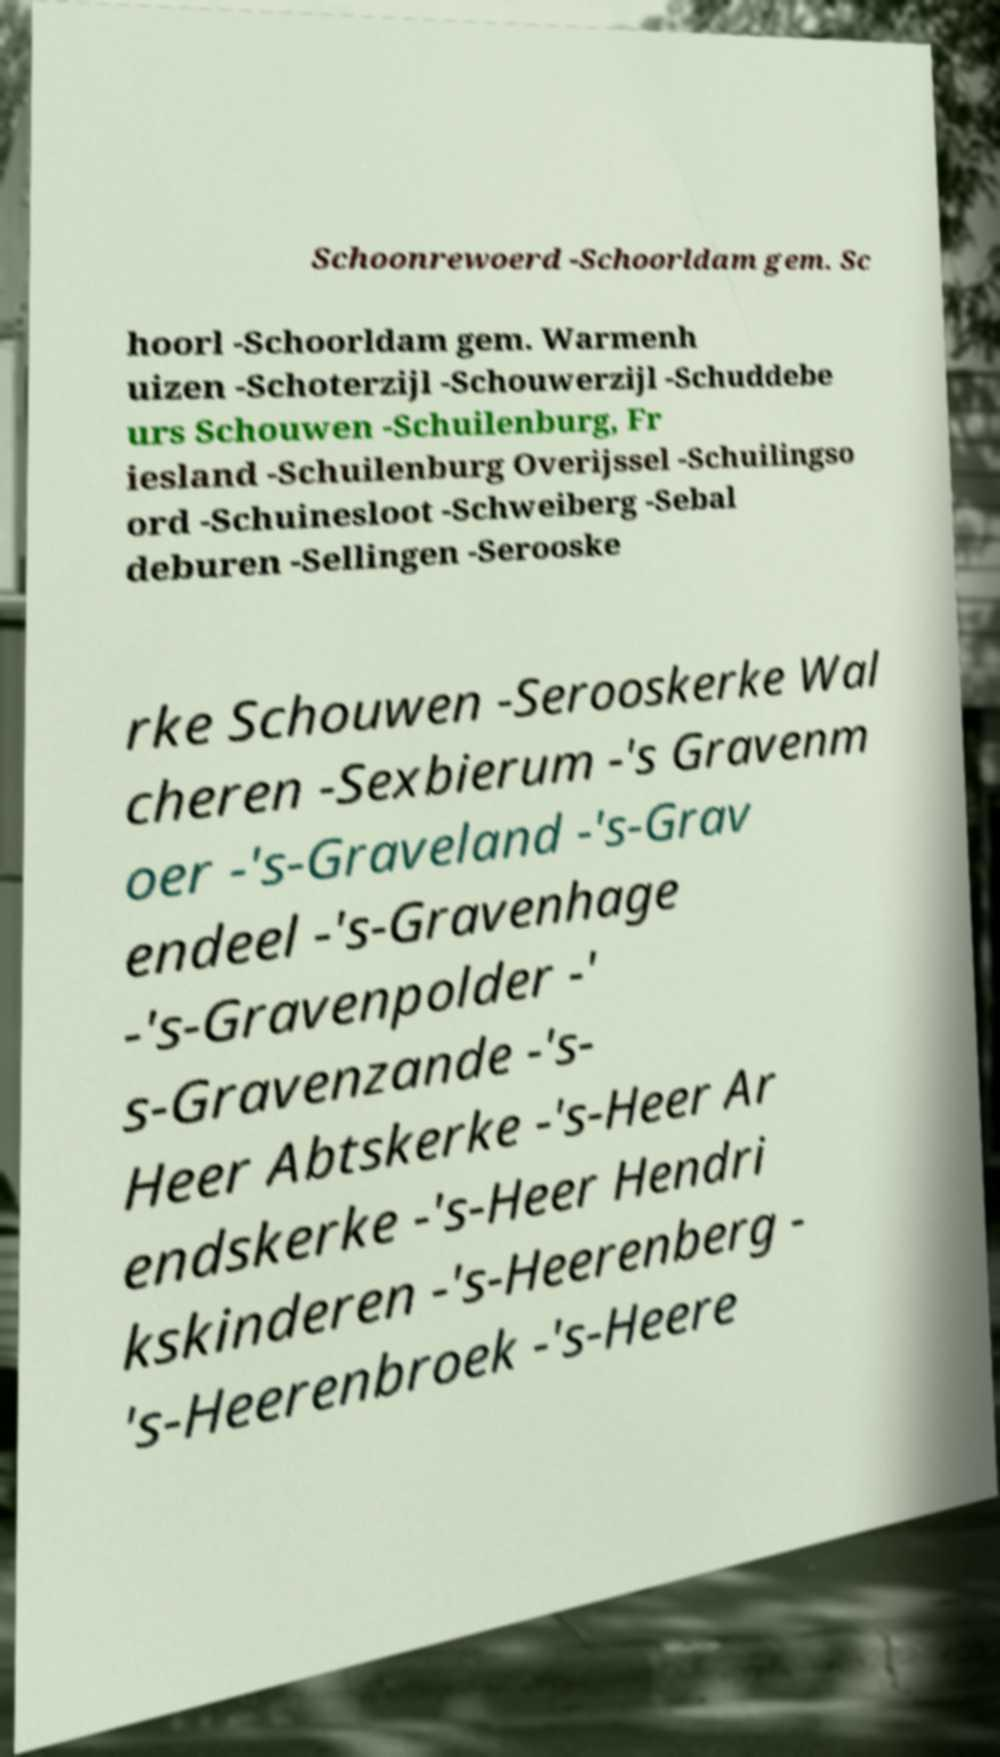Could you extract and type out the text from this image? Schoonrewoerd -Schoorldam gem. Sc hoorl -Schoorldam gem. Warmenh uizen -Schoterzijl -Schouwerzijl -Schuddebe urs Schouwen -Schuilenburg, Fr iesland -Schuilenburg Overijssel -Schuilingso ord -Schuinesloot -Schweiberg -Sebal deburen -Sellingen -Serooske rke Schouwen -Serooskerke Wal cheren -Sexbierum -'s Gravenm oer -'s-Graveland -'s-Grav endeel -'s-Gravenhage -'s-Gravenpolder -' s-Gravenzande -'s- Heer Abtskerke -'s-Heer Ar endskerke -'s-Heer Hendri kskinderen -'s-Heerenberg - 's-Heerenbroek -'s-Heere 